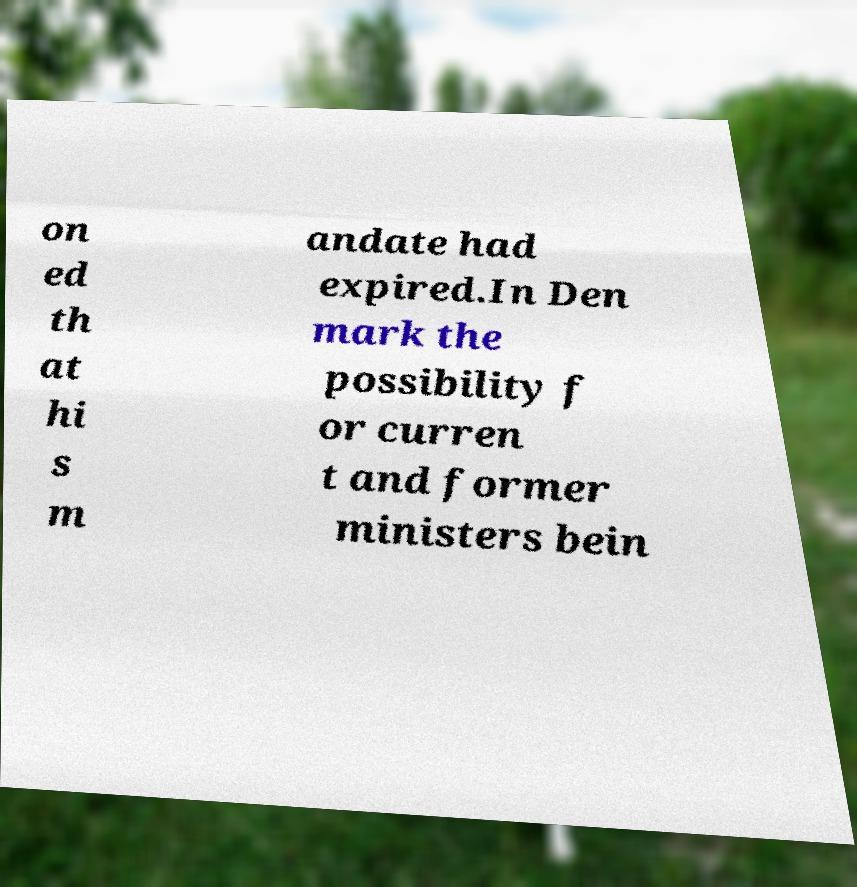Can you accurately transcribe the text from the provided image for me? on ed th at hi s m andate had expired.In Den mark the possibility f or curren t and former ministers bein 